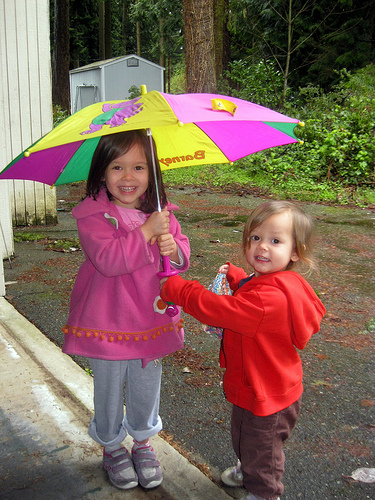How many hands are on the umbrella? The image shows two hands holding the umbrella. It appears that each child is holding it with one hand. 